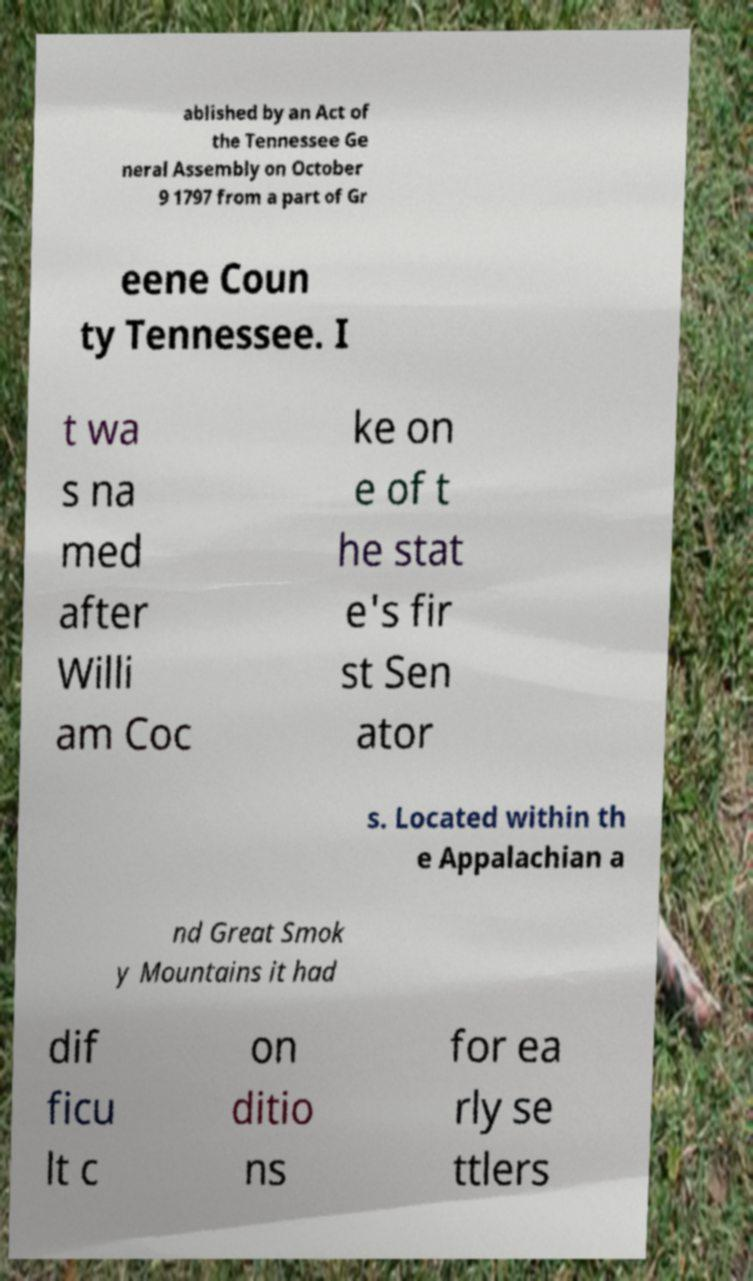For documentation purposes, I need the text within this image transcribed. Could you provide that? ablished by an Act of the Tennessee Ge neral Assembly on October 9 1797 from a part of Gr eene Coun ty Tennessee. I t wa s na med after Willi am Coc ke on e of t he stat e's fir st Sen ator s. Located within th e Appalachian a nd Great Smok y Mountains it had dif ficu lt c on ditio ns for ea rly se ttlers 